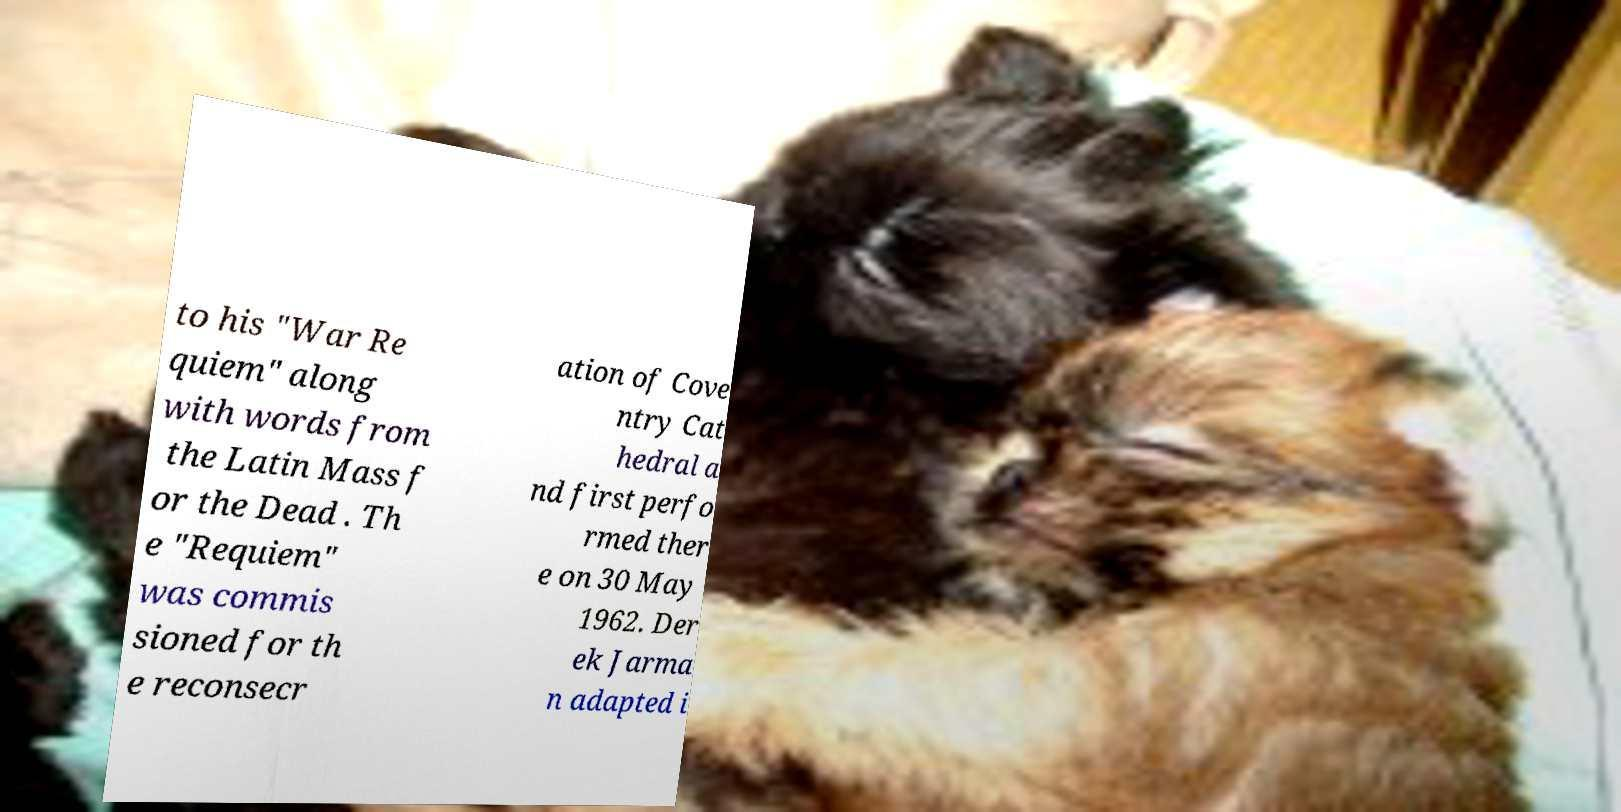Can you read and provide the text displayed in the image?This photo seems to have some interesting text. Can you extract and type it out for me? to his "War Re quiem" along with words from the Latin Mass f or the Dead . Th e "Requiem" was commis sioned for th e reconsecr ation of Cove ntry Cat hedral a nd first perfo rmed ther e on 30 May 1962. Der ek Jarma n adapted i 